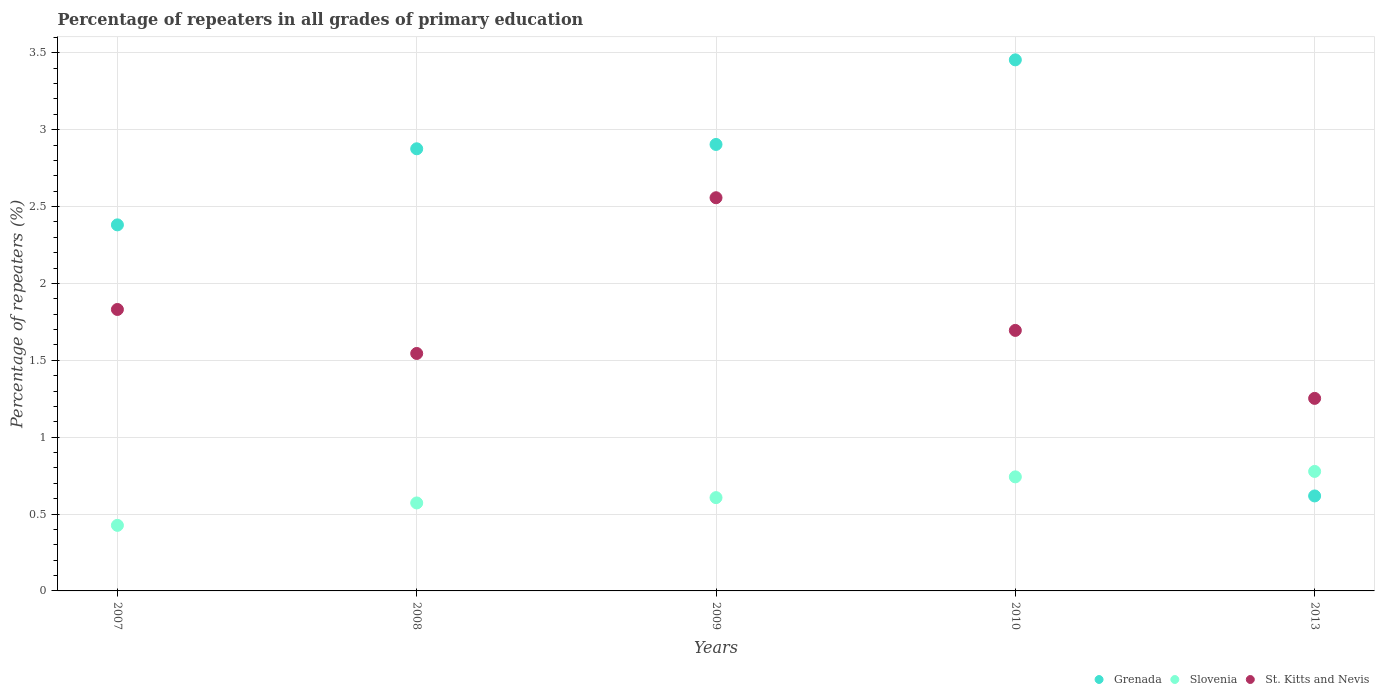How many different coloured dotlines are there?
Ensure brevity in your answer.  3. What is the percentage of repeaters in St. Kitts and Nevis in 2009?
Your answer should be very brief. 2.56. Across all years, what is the maximum percentage of repeaters in St. Kitts and Nevis?
Give a very brief answer. 2.56. Across all years, what is the minimum percentage of repeaters in St. Kitts and Nevis?
Offer a very short reply. 1.25. In which year was the percentage of repeaters in Grenada minimum?
Make the answer very short. 2013. What is the total percentage of repeaters in St. Kitts and Nevis in the graph?
Provide a succinct answer. 8.88. What is the difference between the percentage of repeaters in Grenada in 2007 and that in 2008?
Provide a succinct answer. -0.49. What is the difference between the percentage of repeaters in Slovenia in 2013 and the percentage of repeaters in Grenada in 2010?
Offer a very short reply. -2.68. What is the average percentage of repeaters in Slovenia per year?
Keep it short and to the point. 0.62. In the year 2010, what is the difference between the percentage of repeaters in St. Kitts and Nevis and percentage of repeaters in Slovenia?
Offer a very short reply. 0.95. In how many years, is the percentage of repeaters in St. Kitts and Nevis greater than 1.4 %?
Make the answer very short. 4. What is the ratio of the percentage of repeaters in Slovenia in 2008 to that in 2009?
Offer a very short reply. 0.94. Is the percentage of repeaters in St. Kitts and Nevis in 2007 less than that in 2008?
Your answer should be compact. No. Is the difference between the percentage of repeaters in St. Kitts and Nevis in 2010 and 2013 greater than the difference between the percentage of repeaters in Slovenia in 2010 and 2013?
Your response must be concise. Yes. What is the difference between the highest and the second highest percentage of repeaters in St. Kitts and Nevis?
Provide a short and direct response. 0.73. What is the difference between the highest and the lowest percentage of repeaters in Slovenia?
Provide a succinct answer. 0.35. Does the percentage of repeaters in Grenada monotonically increase over the years?
Keep it short and to the point. No. How many years are there in the graph?
Your answer should be very brief. 5. What is the difference between two consecutive major ticks on the Y-axis?
Your response must be concise. 0.5. Does the graph contain any zero values?
Provide a succinct answer. No. Does the graph contain grids?
Offer a very short reply. Yes. Where does the legend appear in the graph?
Make the answer very short. Bottom right. How many legend labels are there?
Your answer should be very brief. 3. What is the title of the graph?
Give a very brief answer. Percentage of repeaters in all grades of primary education. Does "Sint Maarten (Dutch part)" appear as one of the legend labels in the graph?
Make the answer very short. No. What is the label or title of the Y-axis?
Offer a very short reply. Percentage of repeaters (%). What is the Percentage of repeaters (%) in Grenada in 2007?
Your answer should be compact. 2.38. What is the Percentage of repeaters (%) in Slovenia in 2007?
Give a very brief answer. 0.43. What is the Percentage of repeaters (%) of St. Kitts and Nevis in 2007?
Keep it short and to the point. 1.83. What is the Percentage of repeaters (%) of Grenada in 2008?
Your response must be concise. 2.88. What is the Percentage of repeaters (%) in Slovenia in 2008?
Provide a short and direct response. 0.57. What is the Percentage of repeaters (%) in St. Kitts and Nevis in 2008?
Your answer should be compact. 1.54. What is the Percentage of repeaters (%) of Grenada in 2009?
Make the answer very short. 2.9. What is the Percentage of repeaters (%) in Slovenia in 2009?
Provide a short and direct response. 0.61. What is the Percentage of repeaters (%) of St. Kitts and Nevis in 2009?
Provide a succinct answer. 2.56. What is the Percentage of repeaters (%) in Grenada in 2010?
Offer a terse response. 3.45. What is the Percentage of repeaters (%) in Slovenia in 2010?
Your answer should be compact. 0.74. What is the Percentage of repeaters (%) of St. Kitts and Nevis in 2010?
Give a very brief answer. 1.69. What is the Percentage of repeaters (%) in Grenada in 2013?
Offer a very short reply. 0.62. What is the Percentage of repeaters (%) of Slovenia in 2013?
Offer a terse response. 0.78. What is the Percentage of repeaters (%) in St. Kitts and Nevis in 2013?
Offer a very short reply. 1.25. Across all years, what is the maximum Percentage of repeaters (%) of Grenada?
Provide a succinct answer. 3.45. Across all years, what is the maximum Percentage of repeaters (%) in Slovenia?
Provide a short and direct response. 0.78. Across all years, what is the maximum Percentage of repeaters (%) in St. Kitts and Nevis?
Your response must be concise. 2.56. Across all years, what is the minimum Percentage of repeaters (%) of Grenada?
Provide a succinct answer. 0.62. Across all years, what is the minimum Percentage of repeaters (%) in Slovenia?
Your response must be concise. 0.43. Across all years, what is the minimum Percentage of repeaters (%) in St. Kitts and Nevis?
Your answer should be compact. 1.25. What is the total Percentage of repeaters (%) in Grenada in the graph?
Your response must be concise. 12.23. What is the total Percentage of repeaters (%) in Slovenia in the graph?
Give a very brief answer. 3.12. What is the total Percentage of repeaters (%) in St. Kitts and Nevis in the graph?
Give a very brief answer. 8.88. What is the difference between the Percentage of repeaters (%) in Grenada in 2007 and that in 2008?
Make the answer very short. -0.49. What is the difference between the Percentage of repeaters (%) in Slovenia in 2007 and that in 2008?
Provide a short and direct response. -0.15. What is the difference between the Percentage of repeaters (%) of St. Kitts and Nevis in 2007 and that in 2008?
Ensure brevity in your answer.  0.29. What is the difference between the Percentage of repeaters (%) of Grenada in 2007 and that in 2009?
Your answer should be very brief. -0.52. What is the difference between the Percentage of repeaters (%) of Slovenia in 2007 and that in 2009?
Ensure brevity in your answer.  -0.18. What is the difference between the Percentage of repeaters (%) of St. Kitts and Nevis in 2007 and that in 2009?
Ensure brevity in your answer.  -0.73. What is the difference between the Percentage of repeaters (%) in Grenada in 2007 and that in 2010?
Make the answer very short. -1.07. What is the difference between the Percentage of repeaters (%) of Slovenia in 2007 and that in 2010?
Keep it short and to the point. -0.32. What is the difference between the Percentage of repeaters (%) in St. Kitts and Nevis in 2007 and that in 2010?
Give a very brief answer. 0.14. What is the difference between the Percentage of repeaters (%) in Grenada in 2007 and that in 2013?
Make the answer very short. 1.76. What is the difference between the Percentage of repeaters (%) of Slovenia in 2007 and that in 2013?
Provide a succinct answer. -0.35. What is the difference between the Percentage of repeaters (%) in St. Kitts and Nevis in 2007 and that in 2013?
Give a very brief answer. 0.58. What is the difference between the Percentage of repeaters (%) of Grenada in 2008 and that in 2009?
Ensure brevity in your answer.  -0.03. What is the difference between the Percentage of repeaters (%) in Slovenia in 2008 and that in 2009?
Your response must be concise. -0.03. What is the difference between the Percentage of repeaters (%) of St. Kitts and Nevis in 2008 and that in 2009?
Offer a terse response. -1.01. What is the difference between the Percentage of repeaters (%) in Grenada in 2008 and that in 2010?
Give a very brief answer. -0.58. What is the difference between the Percentage of repeaters (%) of Slovenia in 2008 and that in 2010?
Provide a succinct answer. -0.17. What is the difference between the Percentage of repeaters (%) in Grenada in 2008 and that in 2013?
Your answer should be very brief. 2.26. What is the difference between the Percentage of repeaters (%) of Slovenia in 2008 and that in 2013?
Offer a terse response. -0.21. What is the difference between the Percentage of repeaters (%) in St. Kitts and Nevis in 2008 and that in 2013?
Provide a succinct answer. 0.29. What is the difference between the Percentage of repeaters (%) in Grenada in 2009 and that in 2010?
Offer a terse response. -0.55. What is the difference between the Percentage of repeaters (%) of Slovenia in 2009 and that in 2010?
Provide a succinct answer. -0.14. What is the difference between the Percentage of repeaters (%) of St. Kitts and Nevis in 2009 and that in 2010?
Your answer should be very brief. 0.86. What is the difference between the Percentage of repeaters (%) in Grenada in 2009 and that in 2013?
Your answer should be compact. 2.29. What is the difference between the Percentage of repeaters (%) of Slovenia in 2009 and that in 2013?
Your response must be concise. -0.17. What is the difference between the Percentage of repeaters (%) in St. Kitts and Nevis in 2009 and that in 2013?
Your answer should be compact. 1.31. What is the difference between the Percentage of repeaters (%) in Grenada in 2010 and that in 2013?
Offer a terse response. 2.84. What is the difference between the Percentage of repeaters (%) in Slovenia in 2010 and that in 2013?
Your answer should be very brief. -0.04. What is the difference between the Percentage of repeaters (%) in St. Kitts and Nevis in 2010 and that in 2013?
Make the answer very short. 0.44. What is the difference between the Percentage of repeaters (%) of Grenada in 2007 and the Percentage of repeaters (%) of Slovenia in 2008?
Offer a very short reply. 1.81. What is the difference between the Percentage of repeaters (%) of Grenada in 2007 and the Percentage of repeaters (%) of St. Kitts and Nevis in 2008?
Keep it short and to the point. 0.84. What is the difference between the Percentage of repeaters (%) of Slovenia in 2007 and the Percentage of repeaters (%) of St. Kitts and Nevis in 2008?
Provide a short and direct response. -1.12. What is the difference between the Percentage of repeaters (%) in Grenada in 2007 and the Percentage of repeaters (%) in Slovenia in 2009?
Provide a short and direct response. 1.77. What is the difference between the Percentage of repeaters (%) of Grenada in 2007 and the Percentage of repeaters (%) of St. Kitts and Nevis in 2009?
Offer a very short reply. -0.18. What is the difference between the Percentage of repeaters (%) of Slovenia in 2007 and the Percentage of repeaters (%) of St. Kitts and Nevis in 2009?
Your answer should be very brief. -2.13. What is the difference between the Percentage of repeaters (%) of Grenada in 2007 and the Percentage of repeaters (%) of Slovenia in 2010?
Offer a very short reply. 1.64. What is the difference between the Percentage of repeaters (%) in Grenada in 2007 and the Percentage of repeaters (%) in St. Kitts and Nevis in 2010?
Provide a short and direct response. 0.69. What is the difference between the Percentage of repeaters (%) in Slovenia in 2007 and the Percentage of repeaters (%) in St. Kitts and Nevis in 2010?
Your answer should be compact. -1.27. What is the difference between the Percentage of repeaters (%) in Grenada in 2007 and the Percentage of repeaters (%) in Slovenia in 2013?
Provide a short and direct response. 1.6. What is the difference between the Percentage of repeaters (%) in Grenada in 2007 and the Percentage of repeaters (%) in St. Kitts and Nevis in 2013?
Offer a very short reply. 1.13. What is the difference between the Percentage of repeaters (%) in Slovenia in 2007 and the Percentage of repeaters (%) in St. Kitts and Nevis in 2013?
Your answer should be very brief. -0.83. What is the difference between the Percentage of repeaters (%) of Grenada in 2008 and the Percentage of repeaters (%) of Slovenia in 2009?
Offer a terse response. 2.27. What is the difference between the Percentage of repeaters (%) of Grenada in 2008 and the Percentage of repeaters (%) of St. Kitts and Nevis in 2009?
Make the answer very short. 0.32. What is the difference between the Percentage of repeaters (%) of Slovenia in 2008 and the Percentage of repeaters (%) of St. Kitts and Nevis in 2009?
Offer a very short reply. -1.99. What is the difference between the Percentage of repeaters (%) of Grenada in 2008 and the Percentage of repeaters (%) of Slovenia in 2010?
Ensure brevity in your answer.  2.13. What is the difference between the Percentage of repeaters (%) of Grenada in 2008 and the Percentage of repeaters (%) of St. Kitts and Nevis in 2010?
Give a very brief answer. 1.18. What is the difference between the Percentage of repeaters (%) of Slovenia in 2008 and the Percentage of repeaters (%) of St. Kitts and Nevis in 2010?
Provide a short and direct response. -1.12. What is the difference between the Percentage of repeaters (%) of Grenada in 2008 and the Percentage of repeaters (%) of Slovenia in 2013?
Your response must be concise. 2.1. What is the difference between the Percentage of repeaters (%) of Grenada in 2008 and the Percentage of repeaters (%) of St. Kitts and Nevis in 2013?
Your answer should be compact. 1.62. What is the difference between the Percentage of repeaters (%) in Slovenia in 2008 and the Percentage of repeaters (%) in St. Kitts and Nevis in 2013?
Provide a succinct answer. -0.68. What is the difference between the Percentage of repeaters (%) in Grenada in 2009 and the Percentage of repeaters (%) in Slovenia in 2010?
Make the answer very short. 2.16. What is the difference between the Percentage of repeaters (%) in Grenada in 2009 and the Percentage of repeaters (%) in St. Kitts and Nevis in 2010?
Provide a short and direct response. 1.21. What is the difference between the Percentage of repeaters (%) of Slovenia in 2009 and the Percentage of repeaters (%) of St. Kitts and Nevis in 2010?
Provide a succinct answer. -1.09. What is the difference between the Percentage of repeaters (%) of Grenada in 2009 and the Percentage of repeaters (%) of Slovenia in 2013?
Keep it short and to the point. 2.13. What is the difference between the Percentage of repeaters (%) in Grenada in 2009 and the Percentage of repeaters (%) in St. Kitts and Nevis in 2013?
Your answer should be compact. 1.65. What is the difference between the Percentage of repeaters (%) of Slovenia in 2009 and the Percentage of repeaters (%) of St. Kitts and Nevis in 2013?
Provide a succinct answer. -0.65. What is the difference between the Percentage of repeaters (%) of Grenada in 2010 and the Percentage of repeaters (%) of Slovenia in 2013?
Offer a terse response. 2.68. What is the difference between the Percentage of repeaters (%) of Grenada in 2010 and the Percentage of repeaters (%) of St. Kitts and Nevis in 2013?
Your response must be concise. 2.2. What is the difference between the Percentage of repeaters (%) of Slovenia in 2010 and the Percentage of repeaters (%) of St. Kitts and Nevis in 2013?
Give a very brief answer. -0.51. What is the average Percentage of repeaters (%) of Grenada per year?
Provide a succinct answer. 2.45. What is the average Percentage of repeaters (%) of St. Kitts and Nevis per year?
Your response must be concise. 1.78. In the year 2007, what is the difference between the Percentage of repeaters (%) in Grenada and Percentage of repeaters (%) in Slovenia?
Your response must be concise. 1.95. In the year 2007, what is the difference between the Percentage of repeaters (%) of Grenada and Percentage of repeaters (%) of St. Kitts and Nevis?
Give a very brief answer. 0.55. In the year 2007, what is the difference between the Percentage of repeaters (%) of Slovenia and Percentage of repeaters (%) of St. Kitts and Nevis?
Provide a succinct answer. -1.4. In the year 2008, what is the difference between the Percentage of repeaters (%) of Grenada and Percentage of repeaters (%) of Slovenia?
Provide a succinct answer. 2.3. In the year 2008, what is the difference between the Percentage of repeaters (%) of Grenada and Percentage of repeaters (%) of St. Kitts and Nevis?
Provide a succinct answer. 1.33. In the year 2008, what is the difference between the Percentage of repeaters (%) in Slovenia and Percentage of repeaters (%) in St. Kitts and Nevis?
Provide a succinct answer. -0.97. In the year 2009, what is the difference between the Percentage of repeaters (%) in Grenada and Percentage of repeaters (%) in Slovenia?
Give a very brief answer. 2.3. In the year 2009, what is the difference between the Percentage of repeaters (%) of Grenada and Percentage of repeaters (%) of St. Kitts and Nevis?
Provide a short and direct response. 0.35. In the year 2009, what is the difference between the Percentage of repeaters (%) in Slovenia and Percentage of repeaters (%) in St. Kitts and Nevis?
Your response must be concise. -1.95. In the year 2010, what is the difference between the Percentage of repeaters (%) of Grenada and Percentage of repeaters (%) of Slovenia?
Offer a very short reply. 2.71. In the year 2010, what is the difference between the Percentage of repeaters (%) of Grenada and Percentage of repeaters (%) of St. Kitts and Nevis?
Offer a terse response. 1.76. In the year 2010, what is the difference between the Percentage of repeaters (%) in Slovenia and Percentage of repeaters (%) in St. Kitts and Nevis?
Your response must be concise. -0.95. In the year 2013, what is the difference between the Percentage of repeaters (%) in Grenada and Percentage of repeaters (%) in Slovenia?
Your response must be concise. -0.16. In the year 2013, what is the difference between the Percentage of repeaters (%) in Grenada and Percentage of repeaters (%) in St. Kitts and Nevis?
Your answer should be very brief. -0.63. In the year 2013, what is the difference between the Percentage of repeaters (%) of Slovenia and Percentage of repeaters (%) of St. Kitts and Nevis?
Provide a succinct answer. -0.48. What is the ratio of the Percentage of repeaters (%) in Grenada in 2007 to that in 2008?
Your answer should be compact. 0.83. What is the ratio of the Percentage of repeaters (%) of Slovenia in 2007 to that in 2008?
Keep it short and to the point. 0.75. What is the ratio of the Percentage of repeaters (%) of St. Kitts and Nevis in 2007 to that in 2008?
Ensure brevity in your answer.  1.19. What is the ratio of the Percentage of repeaters (%) of Grenada in 2007 to that in 2009?
Offer a terse response. 0.82. What is the ratio of the Percentage of repeaters (%) in Slovenia in 2007 to that in 2009?
Your answer should be compact. 0.7. What is the ratio of the Percentage of repeaters (%) in St. Kitts and Nevis in 2007 to that in 2009?
Provide a short and direct response. 0.72. What is the ratio of the Percentage of repeaters (%) in Grenada in 2007 to that in 2010?
Provide a short and direct response. 0.69. What is the ratio of the Percentage of repeaters (%) of Slovenia in 2007 to that in 2010?
Your answer should be compact. 0.57. What is the ratio of the Percentage of repeaters (%) of St. Kitts and Nevis in 2007 to that in 2010?
Offer a very short reply. 1.08. What is the ratio of the Percentage of repeaters (%) of Grenada in 2007 to that in 2013?
Make the answer very short. 3.85. What is the ratio of the Percentage of repeaters (%) in Slovenia in 2007 to that in 2013?
Keep it short and to the point. 0.55. What is the ratio of the Percentage of repeaters (%) in St. Kitts and Nevis in 2007 to that in 2013?
Keep it short and to the point. 1.46. What is the ratio of the Percentage of repeaters (%) in Grenada in 2008 to that in 2009?
Your response must be concise. 0.99. What is the ratio of the Percentage of repeaters (%) in Slovenia in 2008 to that in 2009?
Ensure brevity in your answer.  0.94. What is the ratio of the Percentage of repeaters (%) in St. Kitts and Nevis in 2008 to that in 2009?
Give a very brief answer. 0.6. What is the ratio of the Percentage of repeaters (%) of Grenada in 2008 to that in 2010?
Give a very brief answer. 0.83. What is the ratio of the Percentage of repeaters (%) of Slovenia in 2008 to that in 2010?
Ensure brevity in your answer.  0.77. What is the ratio of the Percentage of repeaters (%) of St. Kitts and Nevis in 2008 to that in 2010?
Offer a very short reply. 0.91. What is the ratio of the Percentage of repeaters (%) in Grenada in 2008 to that in 2013?
Make the answer very short. 4.65. What is the ratio of the Percentage of repeaters (%) in Slovenia in 2008 to that in 2013?
Your response must be concise. 0.74. What is the ratio of the Percentage of repeaters (%) of St. Kitts and Nevis in 2008 to that in 2013?
Keep it short and to the point. 1.23. What is the ratio of the Percentage of repeaters (%) in Grenada in 2009 to that in 2010?
Provide a succinct answer. 0.84. What is the ratio of the Percentage of repeaters (%) of Slovenia in 2009 to that in 2010?
Your answer should be very brief. 0.82. What is the ratio of the Percentage of repeaters (%) of St. Kitts and Nevis in 2009 to that in 2010?
Make the answer very short. 1.51. What is the ratio of the Percentage of repeaters (%) in Grenada in 2009 to that in 2013?
Keep it short and to the point. 4.7. What is the ratio of the Percentage of repeaters (%) in Slovenia in 2009 to that in 2013?
Make the answer very short. 0.78. What is the ratio of the Percentage of repeaters (%) of St. Kitts and Nevis in 2009 to that in 2013?
Provide a succinct answer. 2.04. What is the ratio of the Percentage of repeaters (%) of Grenada in 2010 to that in 2013?
Your answer should be very brief. 5.59. What is the ratio of the Percentage of repeaters (%) of Slovenia in 2010 to that in 2013?
Offer a terse response. 0.95. What is the ratio of the Percentage of repeaters (%) in St. Kitts and Nevis in 2010 to that in 2013?
Your answer should be compact. 1.35. What is the difference between the highest and the second highest Percentage of repeaters (%) of Grenada?
Provide a succinct answer. 0.55. What is the difference between the highest and the second highest Percentage of repeaters (%) in Slovenia?
Your answer should be compact. 0.04. What is the difference between the highest and the second highest Percentage of repeaters (%) of St. Kitts and Nevis?
Provide a short and direct response. 0.73. What is the difference between the highest and the lowest Percentage of repeaters (%) in Grenada?
Provide a short and direct response. 2.84. What is the difference between the highest and the lowest Percentage of repeaters (%) in Slovenia?
Keep it short and to the point. 0.35. What is the difference between the highest and the lowest Percentage of repeaters (%) in St. Kitts and Nevis?
Ensure brevity in your answer.  1.31. 